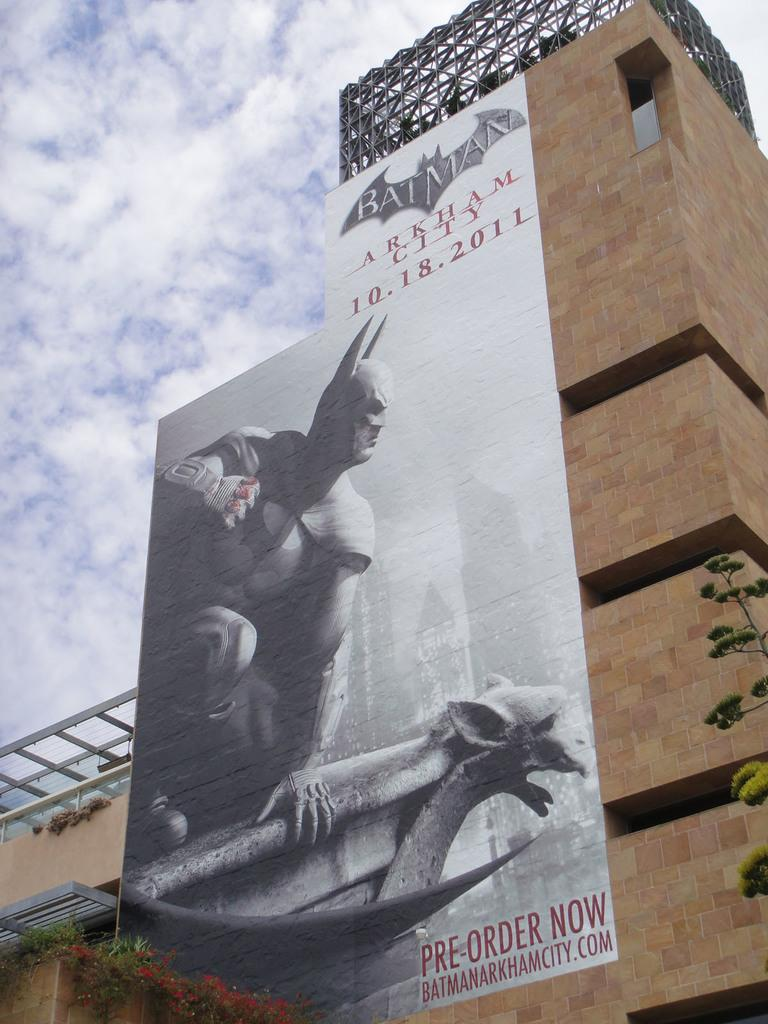<image>
Present a compact description of the photo's key features. Pre oder tickets now for the new Batman movie, Gotham City 